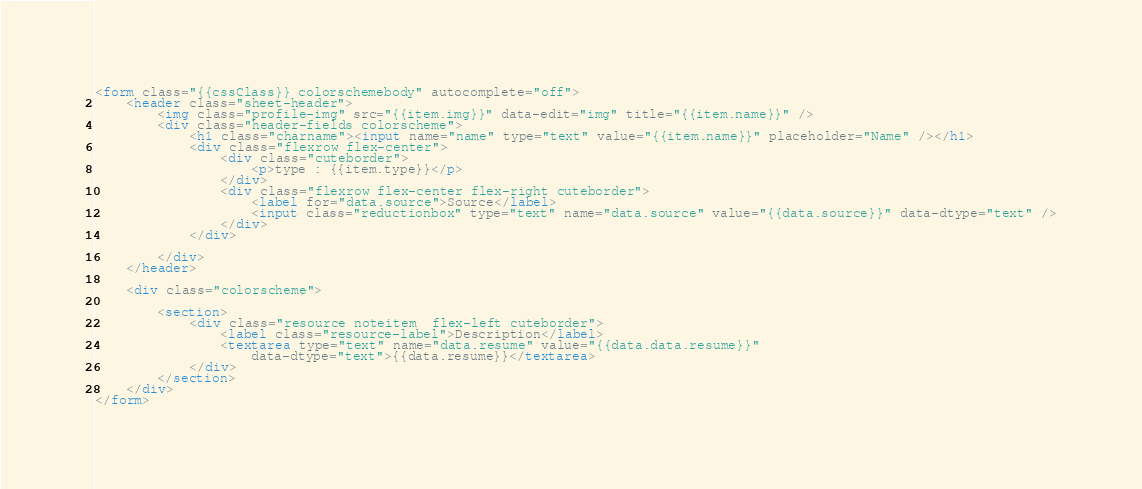Convert code to text. <code><loc_0><loc_0><loc_500><loc_500><_HTML_><form class="{{cssClass}} colorschemebody" autocomplete="off">
    <header class="sheet-header">
        <img class="profile-img" src="{{item.img}}" data-edit="img" title="{{item.name}}" />
        <div class="header-fields colorscheme">
            <h1 class="charname"><input name="name" type="text" value="{{item.name}}" placeholder="Name" /></h1>
            <div class="flexrow flex-center">
                <div class="cuteborder">
                    <p>type : {{item.type}}</p>
                </div>
                <div class="flexrow flex-center flex-right cuteborder">
                    <label for="data.source">Source</label>
                    <input class="reductionbox" type="text" name="data.source" value="{{data.source}}" data-dtype="text" />
                </div>
            </div>
         
        </div>
    </header>

    <div class="colorscheme">

        <section>
            <div class="resource noteitem  flex-left cuteborder">
                <label class="resource-label">Description</label>
                <textarea type="text" name="data.resume" value="{{data.data.resume}}"
                    data-dtype="text">{{data.resume}}</textarea>
            </div>
        </section>
    </div>
</form></code> 